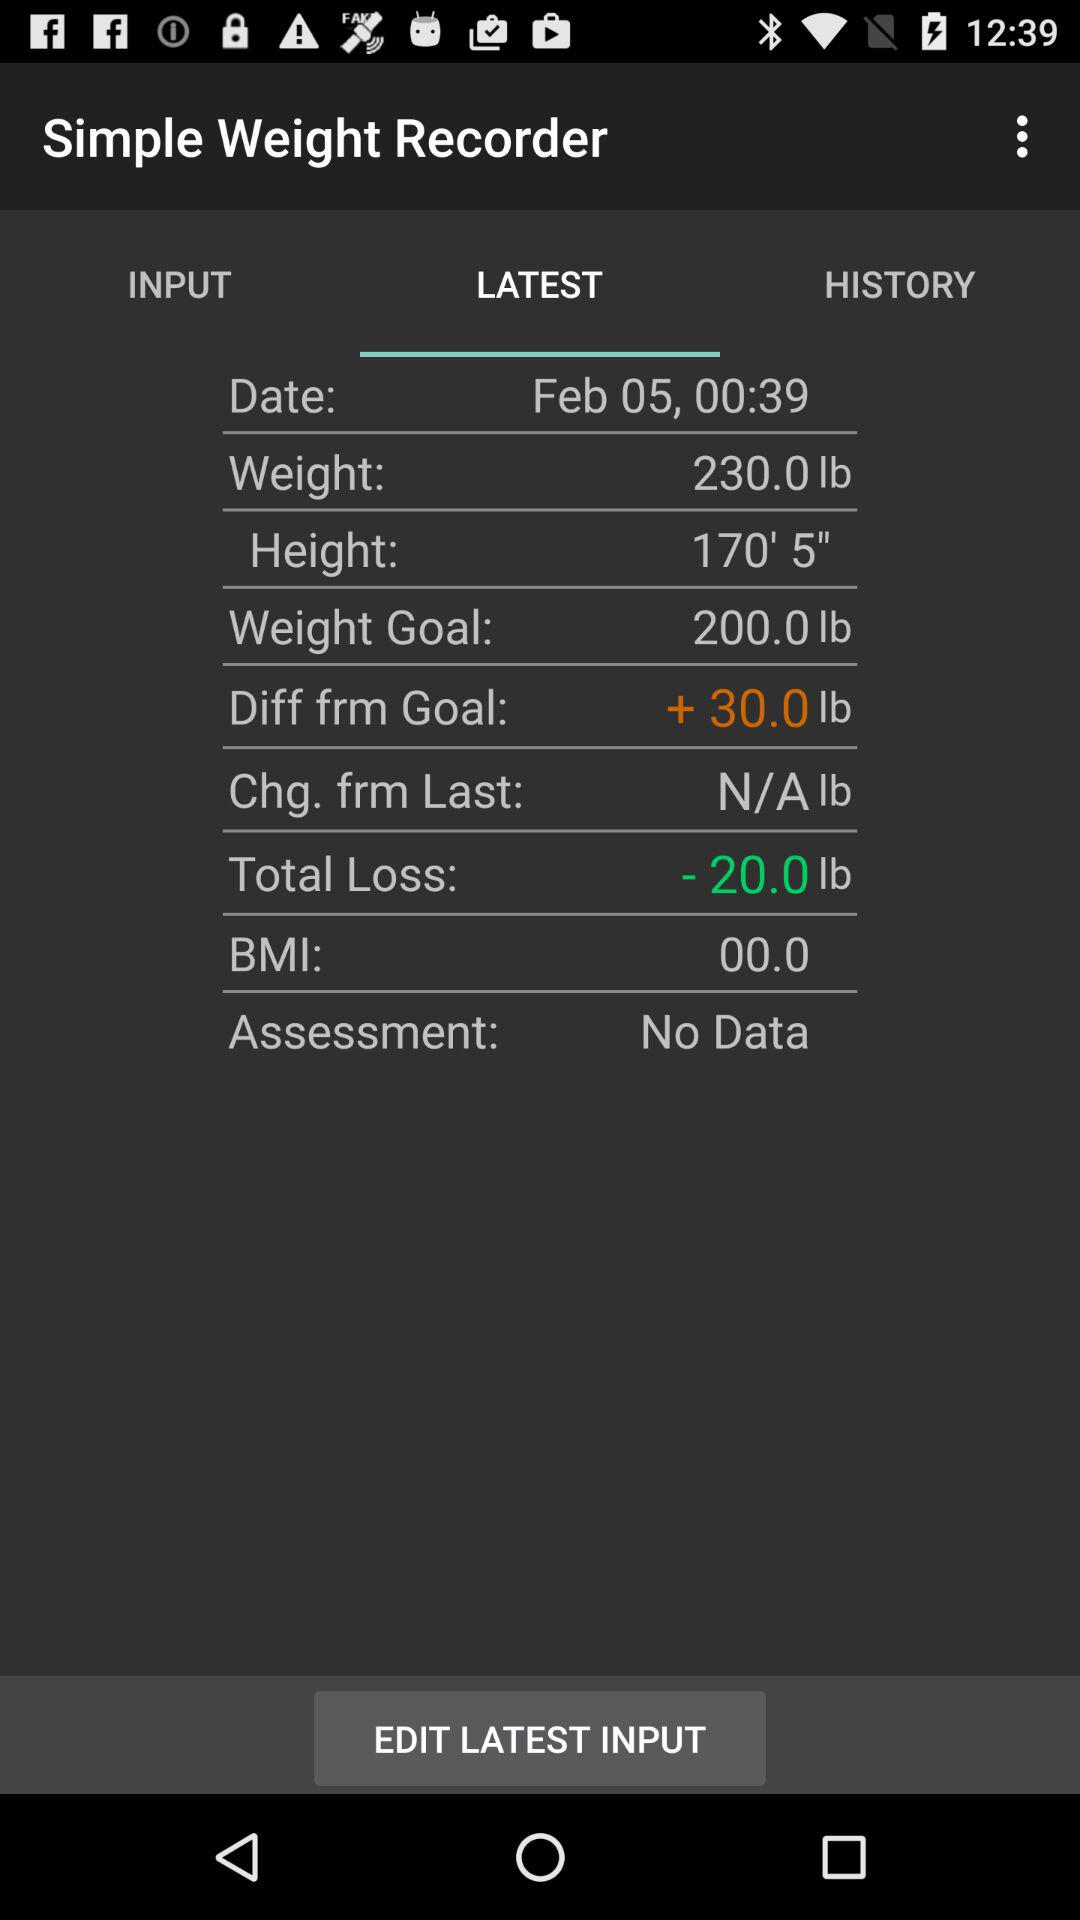What is the total weight loss?
Answer the question using a single word or phrase. -20.0 lb 